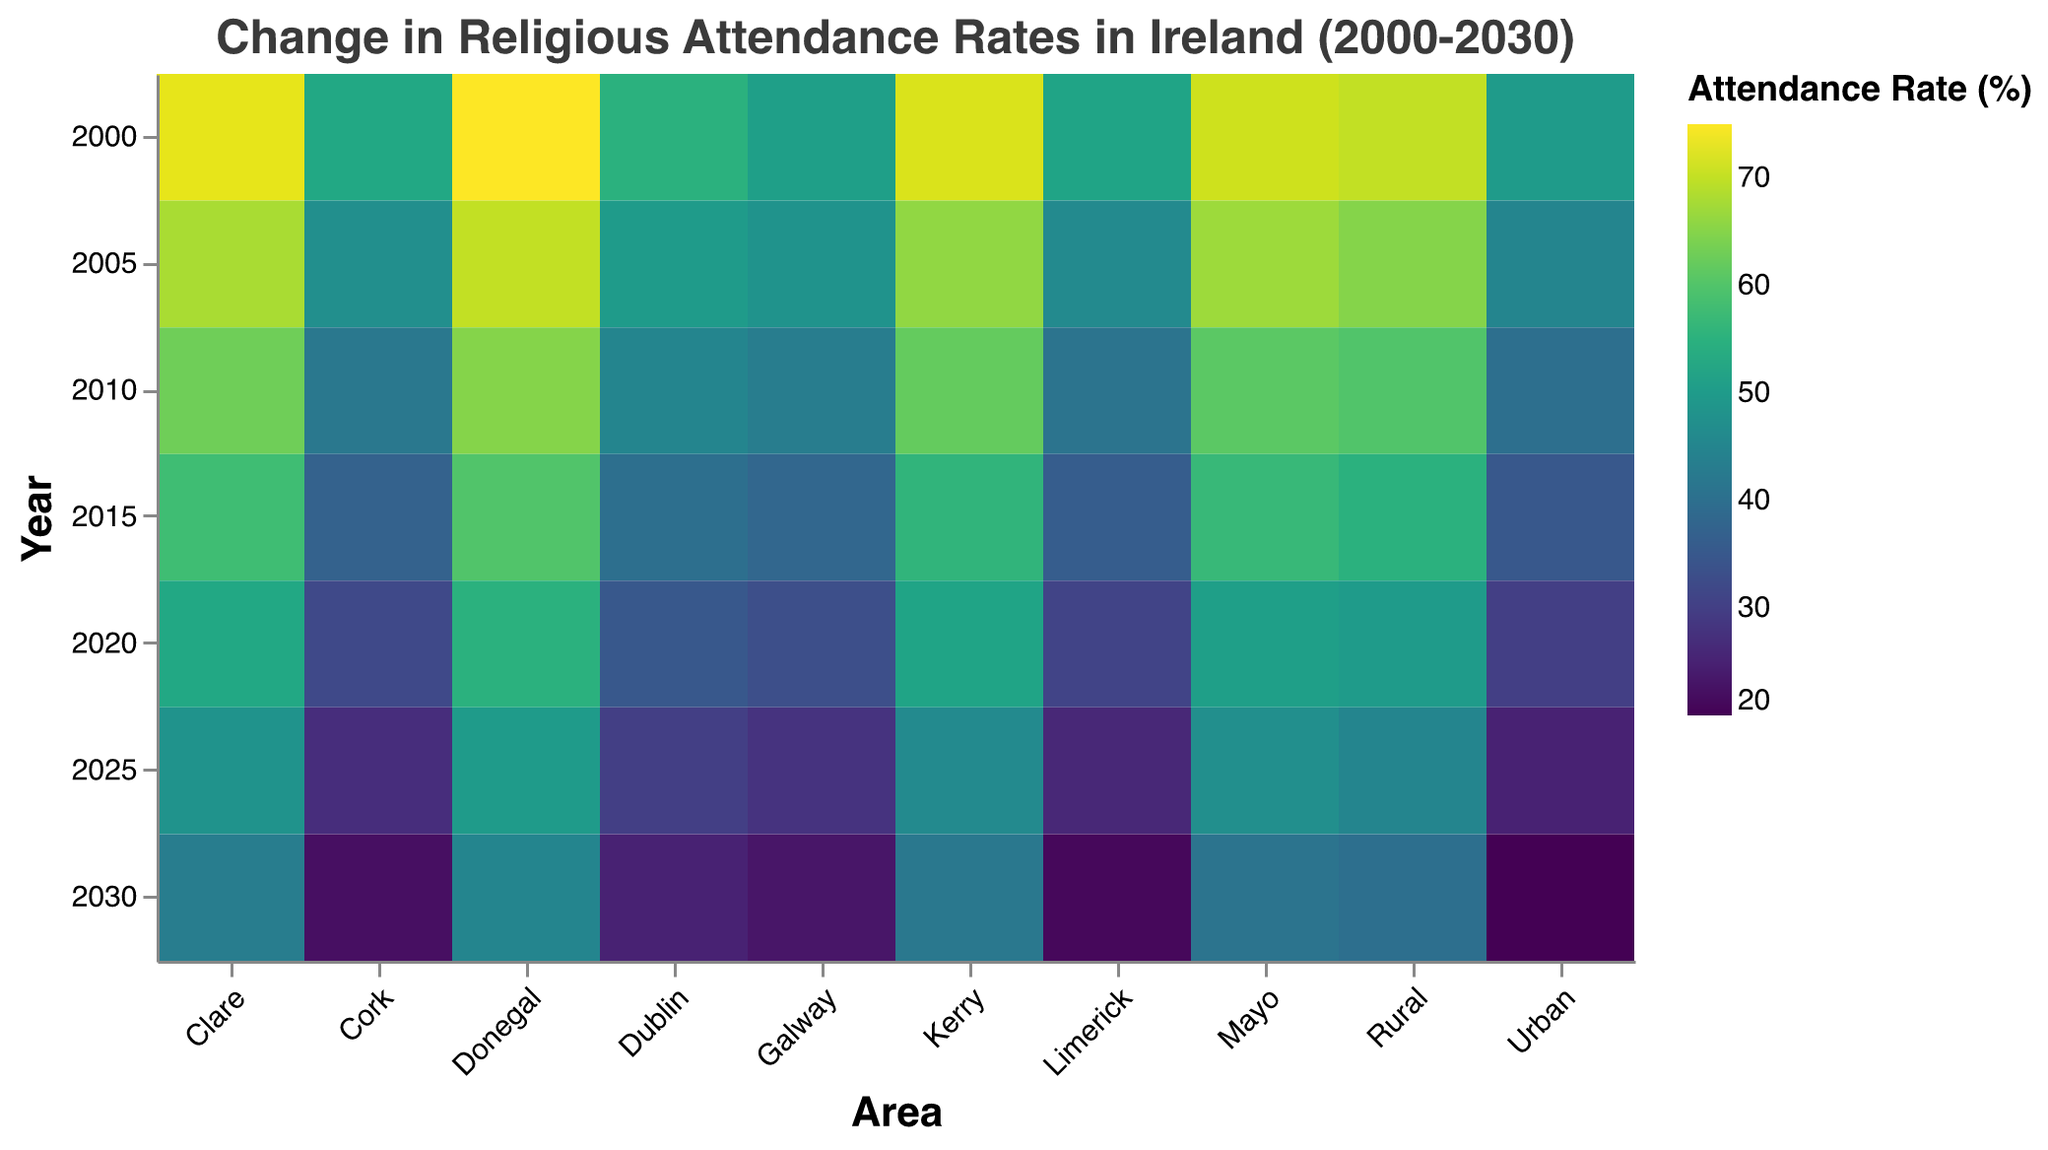How does the attendance rate change for urban areas from 2000 to 2030? The urban attendance rate decreases over time. Start at 50% in 2000, then decrement by 5% every 5 years. By 2030, it is 20%.
Answer: It decreases from 50% in 2000 to 20% in 2030 Which rural area had the highest attendance rate in 2020? To find this, look at the 2020 row for all rural areas (Donegal, Kerry, Clare, Mayo). Donegal has the highest value at 55%.
Answer: Donegal What is the difference in attendance rates between urban and rural areas in 2005? The urban rate in 2005 is 45%, and the rural rate is 65%. Subtract 45% from 65% to get the difference.
Answer: 20% Which region showed the overall biggest decline in attendance rates from 2000 to 2030? Compare the attendance decrease for each region. Donegal has the highest initial rate (75%) and declines to 45%, for a drop of 30%. Verify no other region has a more significant decline.
Answer: Donegal What is the average attendance rate for urban areas in 2025? Find urban attendance values in 2025, which include Urban (25), Dublin (30), Cork (27), Galway (28), and Limerick (26). Sum these values (25+30+27+28+26=136) and divide by 5.
Answer: 27.2% Is the attendance rate for Galway higher or lower than Cork in 2015? Check the values for Galway and Cork in 2015. Galway is 38% and Cork is 37%. Compare these numbers.
Answer: Higher By how much did the attendance rate in Mayo decline from 2000 to 2030? In 2000, Mayo's rate is 71%, and in 2030, it is 41%. Subtract 41% from 71%.
Answer: 30% What's the trend of religious attendance in Ireland from 2000 to 2030 in both urban and rural areas? Identify a steadily decreasing trend in all areas over the 30-year span by observing overall heatmap color changes. Urban areas show more pronounced decline compared to rural.
Answer: Decreasing trend in both urban and rural areas Which year has the lowest overall attendance rates for both urban and rural? Assess all years across the heatmap. Find 2030 has the lowest values for both urban (20%-25%) and rural (40%-45%).
Answer: 2030 How does the pattern of attendance rates over time compare between the areas of Dublin and Clare? Compare the two regions' rates from the heatmap. Both show a decreasing trend, but Dublin's rates are lower than Clare's in every observed year.
Answer: Both decrease, but Dublin is consistently lower than Clare 